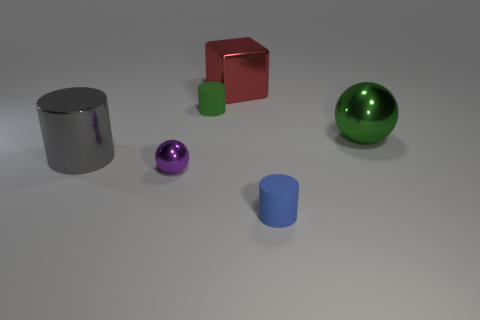What material is the small sphere that is to the left of the small rubber cylinder that is in front of the green rubber thing? metal 